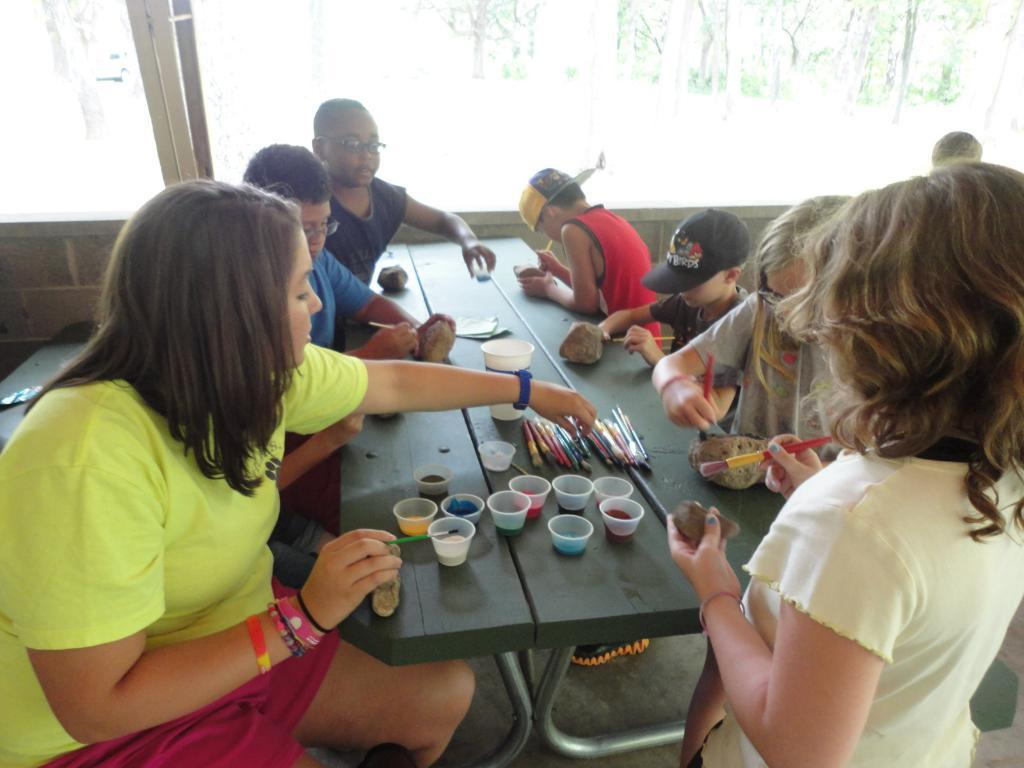How many persons are in the image? There is a group of persons in the image. What are the persons in the image doing? The persons are playing with paint brushes. What type of sugar is being used by the persons in the image? There is no sugar present in the image; the persons are playing with paint brushes. What kind of beast can be seen in the image? There is no beast present in the image; it features a group of persons playing with paint brushes. 